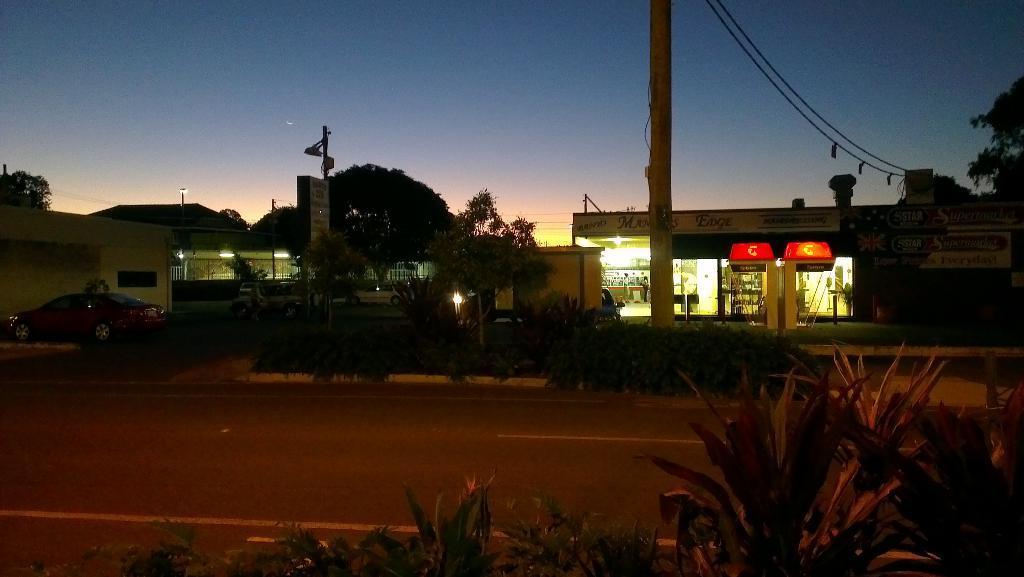Describe this image in one or two sentences. There is a road. Near to the road there are plants. In the back there are trees, plants, buildings and pole. On the left side there is a car. There are lights in the buildings. There is sky in the background. On the right side there is a building with boards on that. 